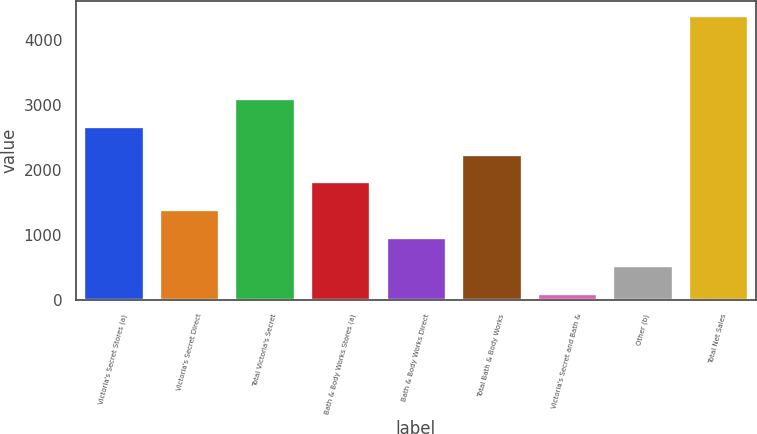Convert chart to OTSL. <chart><loc_0><loc_0><loc_500><loc_500><bar_chart><fcel>Victoria's Secret Stores (a)<fcel>Victoria's Secret Direct<fcel>Total Victoria's Secret<fcel>Bath & Body Works Stores (a)<fcel>Bath & Body Works Direct<fcel>Total Bath & Body Works<fcel>Victoria's Secret and Bath &<fcel>Other (b)<fcel>Total Net Sales<nl><fcel>2681.8<fcel>1396.9<fcel>3110.1<fcel>1825.2<fcel>968.6<fcel>2253.5<fcel>112<fcel>540.3<fcel>4395<nl></chart> 